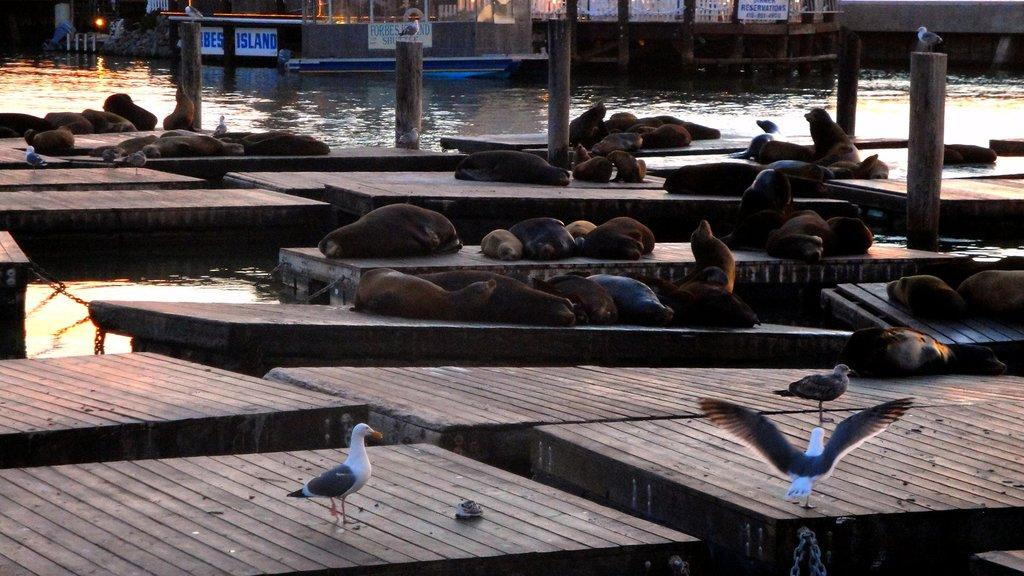What animals can be seen in the image? There are seals and birds in the image. What is the primary element in which the animals are situated? The animals are situated in water. What can be seen in the background of the image? There is a light, posters, and buildings in the background of the image. How many ladybugs can be seen on the bike in the image? There is no bike or ladybugs present in the image. 